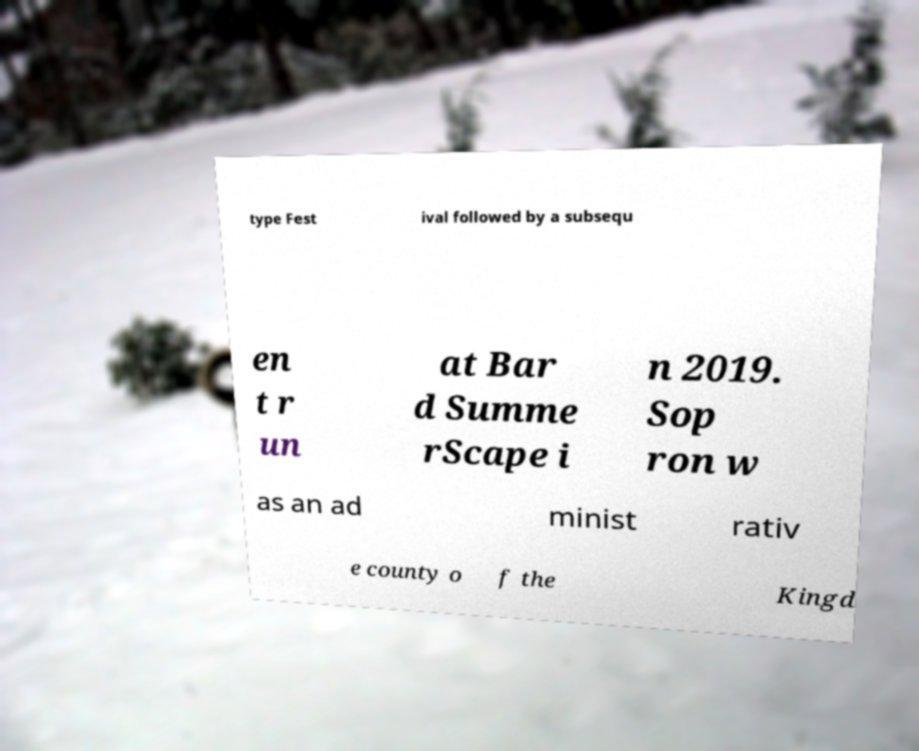I need the written content from this picture converted into text. Can you do that? type Fest ival followed by a subsequ en t r un at Bar d Summe rScape i n 2019. Sop ron w as an ad minist rativ e county o f the Kingd 